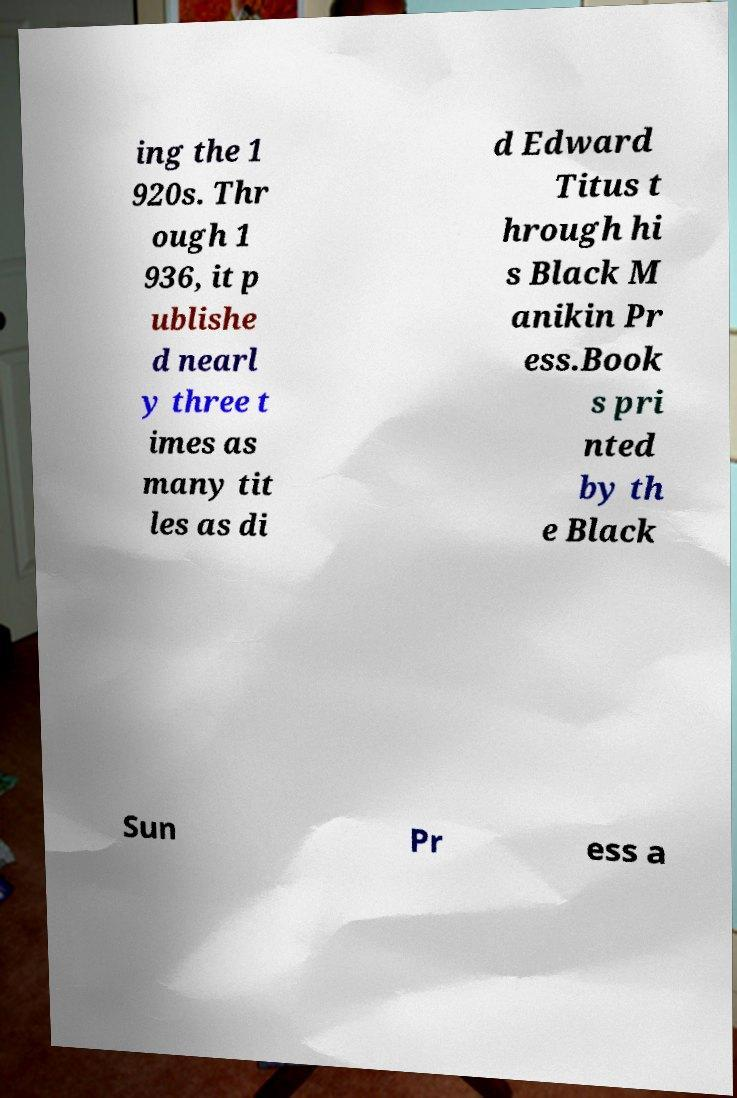Could you assist in decoding the text presented in this image and type it out clearly? ing the 1 920s. Thr ough 1 936, it p ublishe d nearl y three t imes as many tit les as di d Edward Titus t hrough hi s Black M anikin Pr ess.Book s pri nted by th e Black Sun Pr ess a 